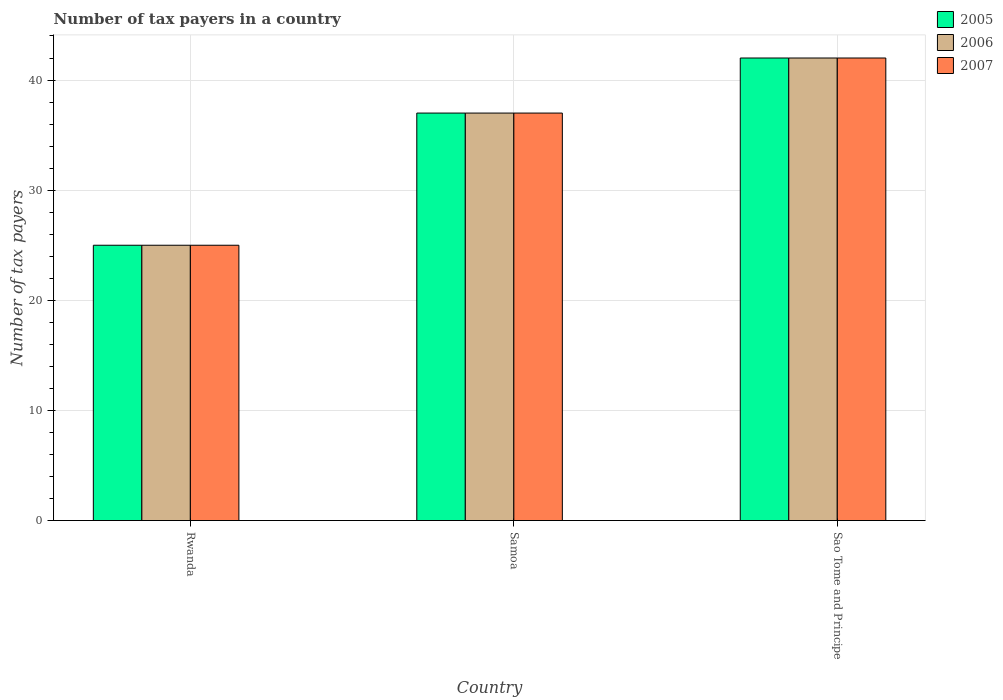How many different coloured bars are there?
Offer a very short reply. 3. How many groups of bars are there?
Provide a short and direct response. 3. Are the number of bars per tick equal to the number of legend labels?
Offer a terse response. Yes. Are the number of bars on each tick of the X-axis equal?
Make the answer very short. Yes. How many bars are there on the 3rd tick from the right?
Give a very brief answer. 3. What is the label of the 1st group of bars from the left?
Your answer should be compact. Rwanda. In how many cases, is the number of bars for a given country not equal to the number of legend labels?
Your answer should be compact. 0. Across all countries, what is the minimum number of tax payers in in 2005?
Offer a very short reply. 25. In which country was the number of tax payers in in 2006 maximum?
Your response must be concise. Sao Tome and Principe. In which country was the number of tax payers in in 2005 minimum?
Provide a succinct answer. Rwanda. What is the total number of tax payers in in 2005 in the graph?
Offer a terse response. 104. What is the difference between the number of tax payers in in 2005 in Sao Tome and Principe and the number of tax payers in in 2007 in Rwanda?
Ensure brevity in your answer.  17. What is the average number of tax payers in in 2006 per country?
Ensure brevity in your answer.  34.67. In how many countries, is the number of tax payers in in 2005 greater than 38?
Offer a terse response. 1. What is the ratio of the number of tax payers in in 2007 in Rwanda to that in Samoa?
Give a very brief answer. 0.68. In how many countries, is the number of tax payers in in 2005 greater than the average number of tax payers in in 2005 taken over all countries?
Give a very brief answer. 2. Is the sum of the number of tax payers in in 2005 in Samoa and Sao Tome and Principe greater than the maximum number of tax payers in in 2007 across all countries?
Make the answer very short. Yes. What does the 2nd bar from the right in Sao Tome and Principe represents?
Your answer should be very brief. 2006. How many bars are there?
Provide a succinct answer. 9. Are all the bars in the graph horizontal?
Make the answer very short. No. How many countries are there in the graph?
Provide a succinct answer. 3. What is the difference between two consecutive major ticks on the Y-axis?
Keep it short and to the point. 10. Are the values on the major ticks of Y-axis written in scientific E-notation?
Your answer should be very brief. No. Does the graph contain grids?
Offer a very short reply. Yes. Where does the legend appear in the graph?
Keep it short and to the point. Top right. How many legend labels are there?
Provide a succinct answer. 3. How are the legend labels stacked?
Your answer should be compact. Vertical. What is the title of the graph?
Provide a succinct answer. Number of tax payers in a country. Does "1991" appear as one of the legend labels in the graph?
Offer a terse response. No. What is the label or title of the X-axis?
Make the answer very short. Country. What is the label or title of the Y-axis?
Keep it short and to the point. Number of tax payers. What is the Number of tax payers in 2005 in Rwanda?
Keep it short and to the point. 25. What is the Number of tax payers of 2006 in Sao Tome and Principe?
Give a very brief answer. 42. What is the Number of tax payers in 2007 in Sao Tome and Principe?
Offer a terse response. 42. Across all countries, what is the maximum Number of tax payers of 2006?
Offer a terse response. 42. Across all countries, what is the minimum Number of tax payers of 2007?
Your response must be concise. 25. What is the total Number of tax payers of 2005 in the graph?
Your answer should be compact. 104. What is the total Number of tax payers in 2006 in the graph?
Your answer should be very brief. 104. What is the total Number of tax payers in 2007 in the graph?
Offer a very short reply. 104. What is the difference between the Number of tax payers of 2005 in Rwanda and that in Samoa?
Offer a very short reply. -12. What is the difference between the Number of tax payers of 2006 in Rwanda and that in Sao Tome and Principe?
Offer a terse response. -17. What is the difference between the Number of tax payers of 2005 in Samoa and that in Sao Tome and Principe?
Provide a succinct answer. -5. What is the difference between the Number of tax payers of 2005 in Rwanda and the Number of tax payers of 2007 in Samoa?
Ensure brevity in your answer.  -12. What is the difference between the Number of tax payers of 2005 in Rwanda and the Number of tax payers of 2006 in Sao Tome and Principe?
Your answer should be very brief. -17. What is the difference between the Number of tax payers of 2005 in Samoa and the Number of tax payers of 2006 in Sao Tome and Principe?
Offer a very short reply. -5. What is the difference between the Number of tax payers in 2005 in Samoa and the Number of tax payers in 2007 in Sao Tome and Principe?
Provide a short and direct response. -5. What is the average Number of tax payers in 2005 per country?
Provide a succinct answer. 34.67. What is the average Number of tax payers in 2006 per country?
Your response must be concise. 34.67. What is the average Number of tax payers of 2007 per country?
Provide a short and direct response. 34.67. What is the difference between the Number of tax payers in 2005 and Number of tax payers in 2006 in Rwanda?
Offer a terse response. 0. What is the difference between the Number of tax payers in 2005 and Number of tax payers in 2007 in Rwanda?
Offer a terse response. 0. What is the difference between the Number of tax payers in 2006 and Number of tax payers in 2007 in Rwanda?
Make the answer very short. 0. What is the difference between the Number of tax payers in 2005 and Number of tax payers in 2007 in Samoa?
Provide a short and direct response. 0. What is the difference between the Number of tax payers of 2006 and Number of tax payers of 2007 in Samoa?
Keep it short and to the point. 0. What is the difference between the Number of tax payers of 2005 and Number of tax payers of 2007 in Sao Tome and Principe?
Offer a terse response. 0. What is the ratio of the Number of tax payers of 2005 in Rwanda to that in Samoa?
Keep it short and to the point. 0.68. What is the ratio of the Number of tax payers of 2006 in Rwanda to that in Samoa?
Ensure brevity in your answer.  0.68. What is the ratio of the Number of tax payers in 2007 in Rwanda to that in Samoa?
Your response must be concise. 0.68. What is the ratio of the Number of tax payers in 2005 in Rwanda to that in Sao Tome and Principe?
Give a very brief answer. 0.6. What is the ratio of the Number of tax payers in 2006 in Rwanda to that in Sao Tome and Principe?
Keep it short and to the point. 0.6. What is the ratio of the Number of tax payers in 2007 in Rwanda to that in Sao Tome and Principe?
Your answer should be very brief. 0.6. What is the ratio of the Number of tax payers of 2005 in Samoa to that in Sao Tome and Principe?
Provide a succinct answer. 0.88. What is the ratio of the Number of tax payers in 2006 in Samoa to that in Sao Tome and Principe?
Your response must be concise. 0.88. What is the ratio of the Number of tax payers of 2007 in Samoa to that in Sao Tome and Principe?
Your answer should be compact. 0.88. What is the difference between the highest and the second highest Number of tax payers in 2005?
Offer a terse response. 5. 